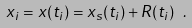Convert formula to latex. <formula><loc_0><loc_0><loc_500><loc_500>x _ { i } = x ( t _ { i } ) = x _ { s } ( t _ { i } ) + R ( t _ { i } ) \ .</formula> 